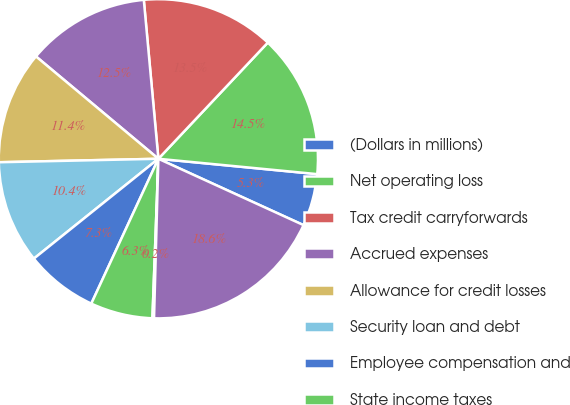Convert chart. <chart><loc_0><loc_0><loc_500><loc_500><pie_chart><fcel>(Dollars in millions)<fcel>Net operating loss<fcel>Tax credit carryforwards<fcel>Accrued expenses<fcel>Allowance for credit losses<fcel>Security loan and debt<fcel>Employee compensation and<fcel>State income taxes<fcel>Other<fcel>Gross deferred tax assets<nl><fcel>5.29%<fcel>14.51%<fcel>13.48%<fcel>12.46%<fcel>11.43%<fcel>10.41%<fcel>7.34%<fcel>6.31%<fcel>0.16%<fcel>18.61%<nl></chart> 